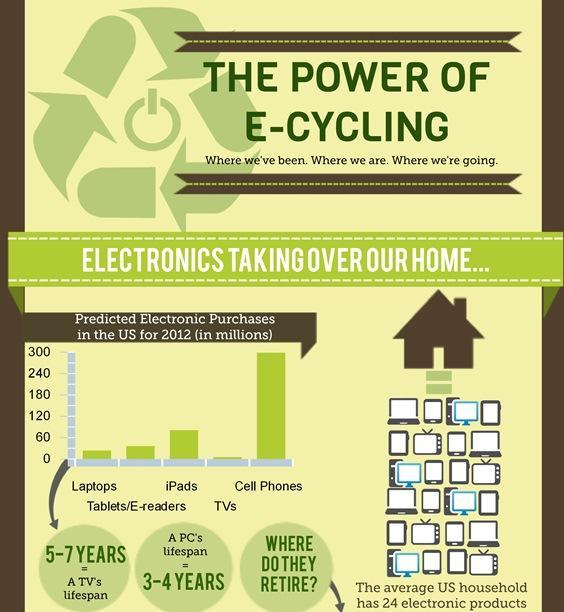Which device has second highest predicted electronic purchase?
Answer the question with a short phrase. iPads Which three devices  have purchases less than 60 million? Laptops, TVs, tablets/e-readers Which two devices have purchases more than 60 million? Cell phones, iPads What is the lifespan of a PC? 3 - 4 years Which device has the lowest predicted electronic purchase? TVs What is the lifespan of a TV? 5 - 7 years 